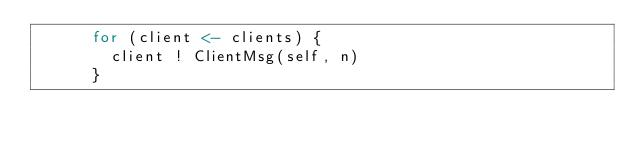<code> <loc_0><loc_0><loc_500><loc_500><_Scala_>      for (client <- clients) {
        client ! ClientMsg(self, n)
      }</code> 